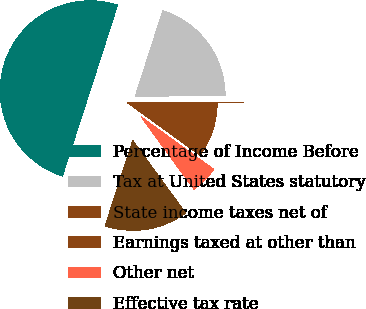Convert chart. <chart><loc_0><loc_0><loc_500><loc_500><pie_chart><fcel>Percentage of Income Before<fcel>Tax at United States statutory<fcel>State income taxes net of<fcel>Earnings taxed at other than<fcel>Other net<fcel>Effective tax rate<nl><fcel>49.97%<fcel>20.0%<fcel>0.01%<fcel>10.01%<fcel>5.01%<fcel>15.0%<nl></chart> 